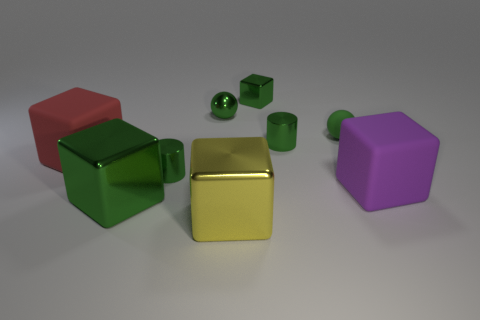There is a large thing that is the same color as the rubber ball; what is its material?
Offer a terse response. Metal. How many other metal cubes have the same color as the small metal cube?
Your answer should be very brief. 1. The yellow metallic object has what size?
Offer a terse response. Large. There is a yellow metallic thing; is its shape the same as the rubber object in front of the red thing?
Your answer should be very brief. Yes. The tiny thing that is made of the same material as the big purple block is what color?
Make the answer very short. Green. There is a green cylinder on the right side of the yellow cube; what is its size?
Provide a succinct answer. Small. Are there fewer red blocks behind the large red rubber object than small cylinders?
Your response must be concise. Yes. Do the metallic ball and the small cube have the same color?
Ensure brevity in your answer.  Yes. Is there anything else that is the same shape as the big green object?
Offer a terse response. Yes. Is the number of big yellow shiny objects less than the number of large gray matte cubes?
Offer a terse response. No. 